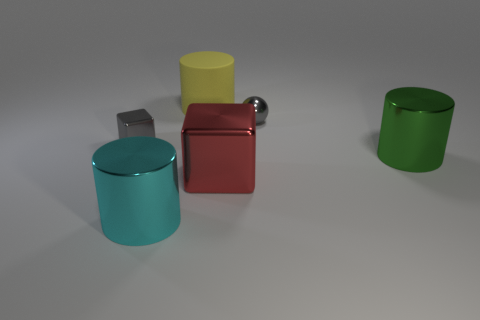Considering the arrangement, what might these objects represent or symbolize? The objects' arrangement with different colors and their distinct shapes could represent diversity and individuality. Despite their differences, the positioning suggests a harmonious coexistence, possibly symbolizing unity in diversity or the blending of unique qualities within a group. 